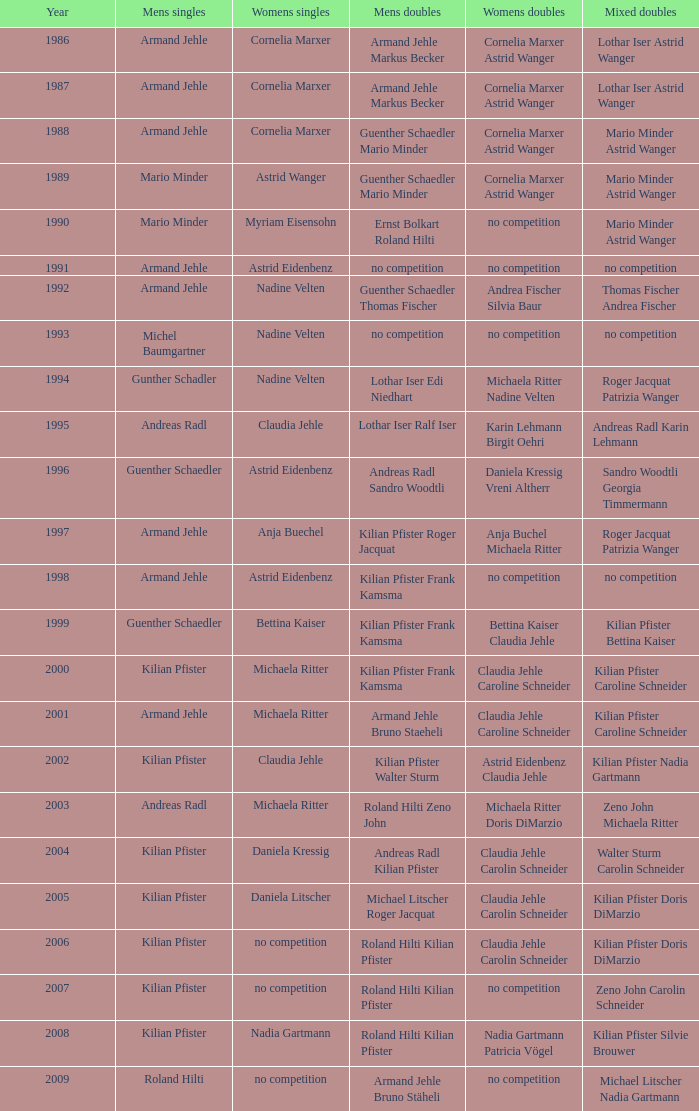In 2001, where the mens singles is armand jehle and the womens singles is michaela ritter, who are the mixed doubles Kilian Pfister Caroline Schneider. 